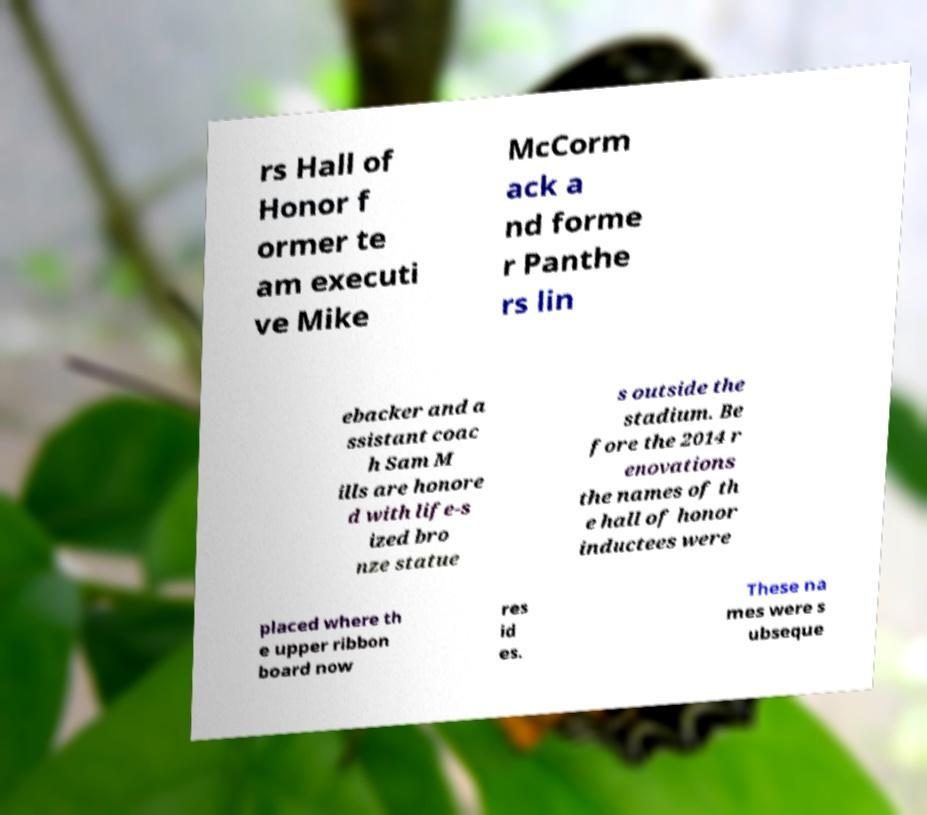Please identify and transcribe the text found in this image. rs Hall of Honor f ormer te am executi ve Mike McCorm ack a nd forme r Panthe rs lin ebacker and a ssistant coac h Sam M ills are honore d with life-s ized bro nze statue s outside the stadium. Be fore the 2014 r enovations the names of th e hall of honor inductees were placed where th e upper ribbon board now res id es. These na mes were s ubseque 